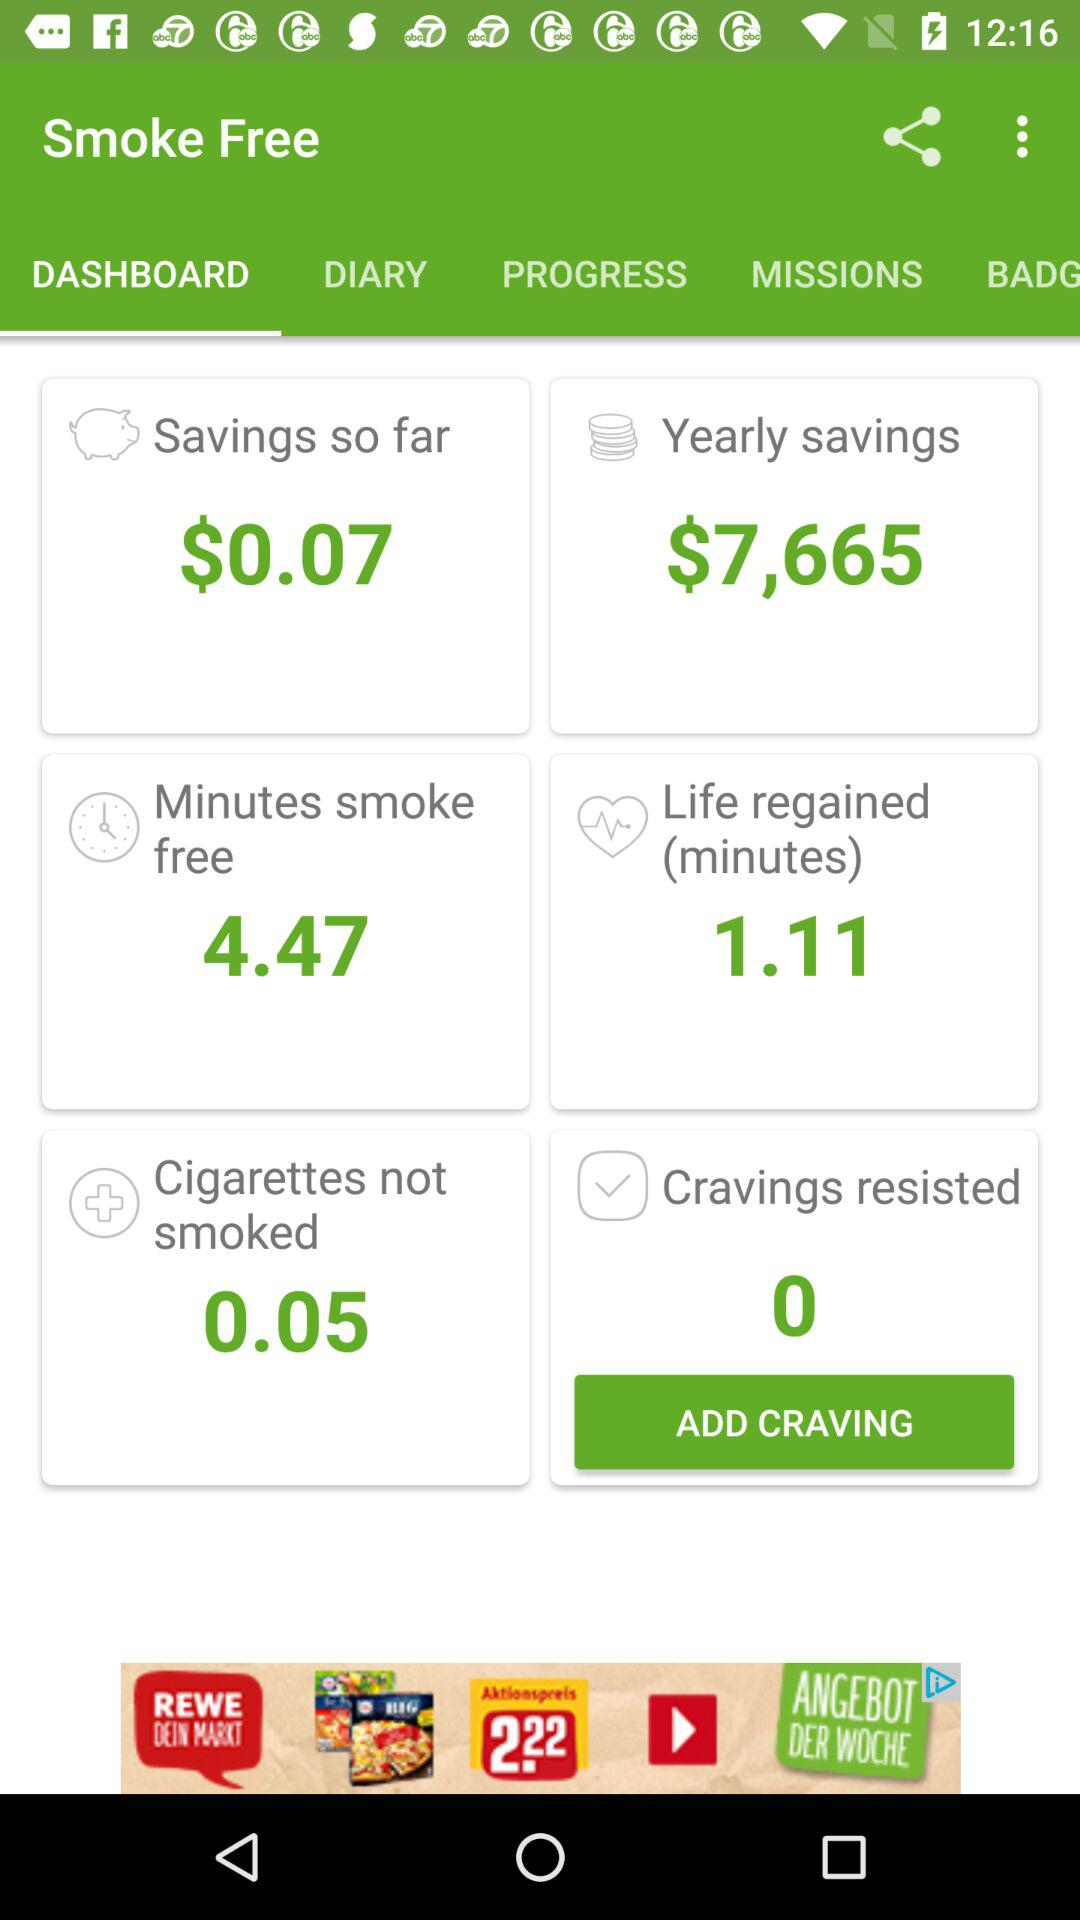What is the time duration of the life regained? The time duration of the life regained is 1.11 minutes. 